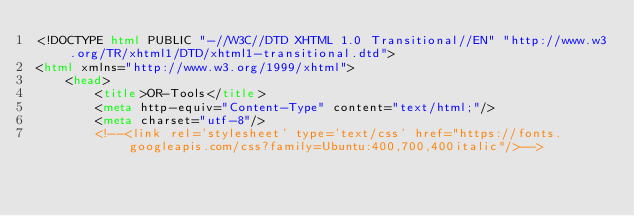Convert code to text. <code><loc_0><loc_0><loc_500><loc_500><_HTML_><!DOCTYPE html PUBLIC "-//W3C//DTD XHTML 1.0 Transitional//EN" "http://www.w3.org/TR/xhtml1/DTD/xhtml1-transitional.dtd">
<html xmlns="http://www.w3.org/1999/xhtml">
    <head>
        <title>OR-Tools</title>
        <meta http-equiv="Content-Type" content="text/html;"/>
        <meta charset="utf-8"/>
        <!--<link rel='stylesheet' type='text/css' href="https://fonts.googleapis.com/css?family=Ubuntu:400,700,400italic"/>--></code> 